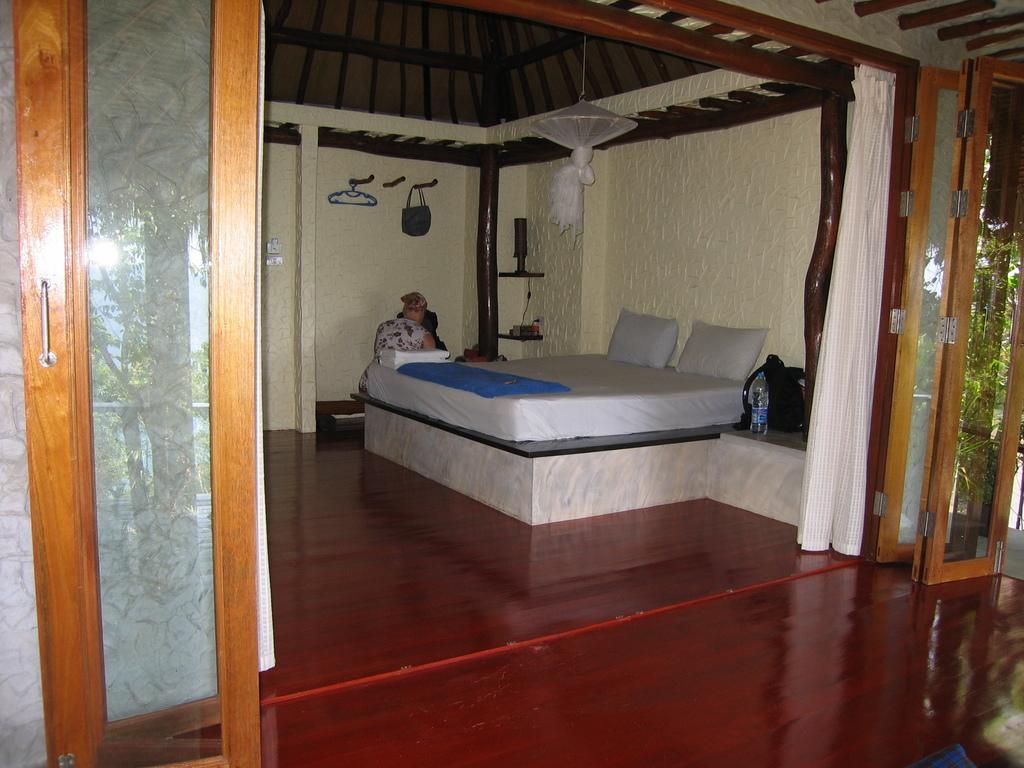Describe this image in one or two sentences. In the picture there is a bedroom, there is a bed and there are pillows present, beside the bed there is a bag, there is a bottle, there is a person sitting beside the bed, on the wall there are hangers, there is a bag hanging on the hanger, there are glass doors present, there are trees. 